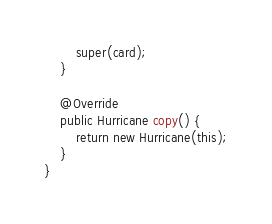Convert code to text. <code><loc_0><loc_0><loc_500><loc_500><_Java_>        super(card);
    }

    @Override
    public Hurricane copy() {
        return new Hurricane(this);
    }
}
</code> 